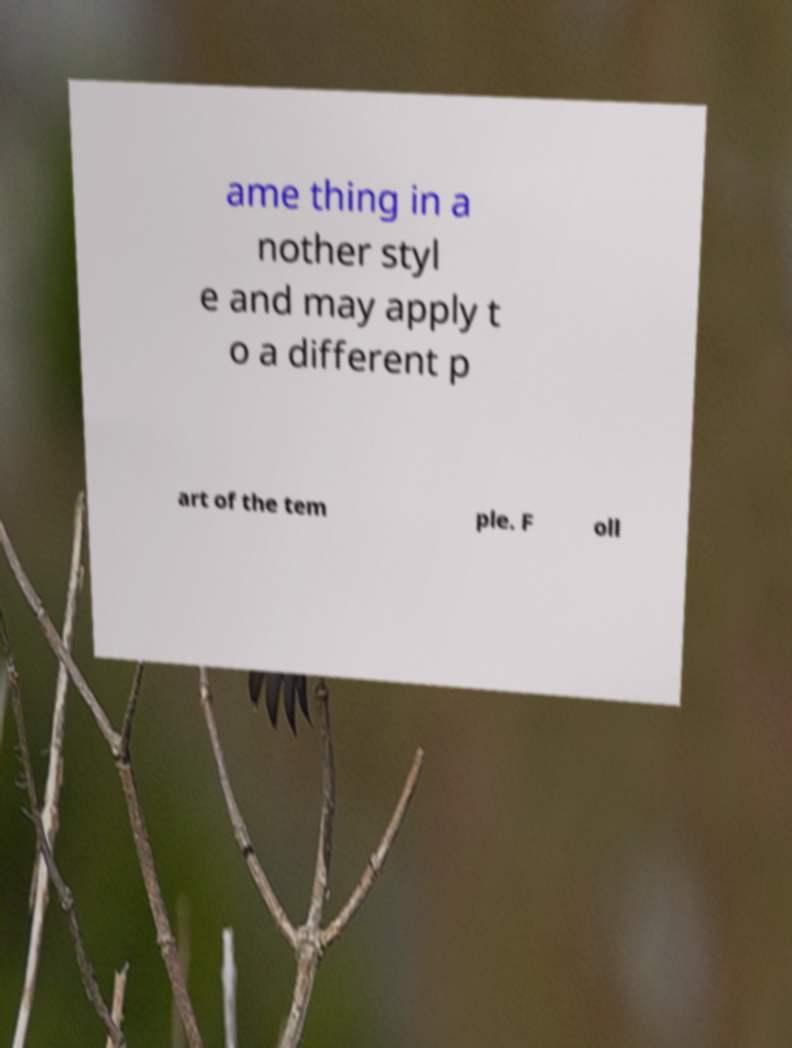Please identify and transcribe the text found in this image. ame thing in a nother styl e and may apply t o a different p art of the tem ple. F oll 